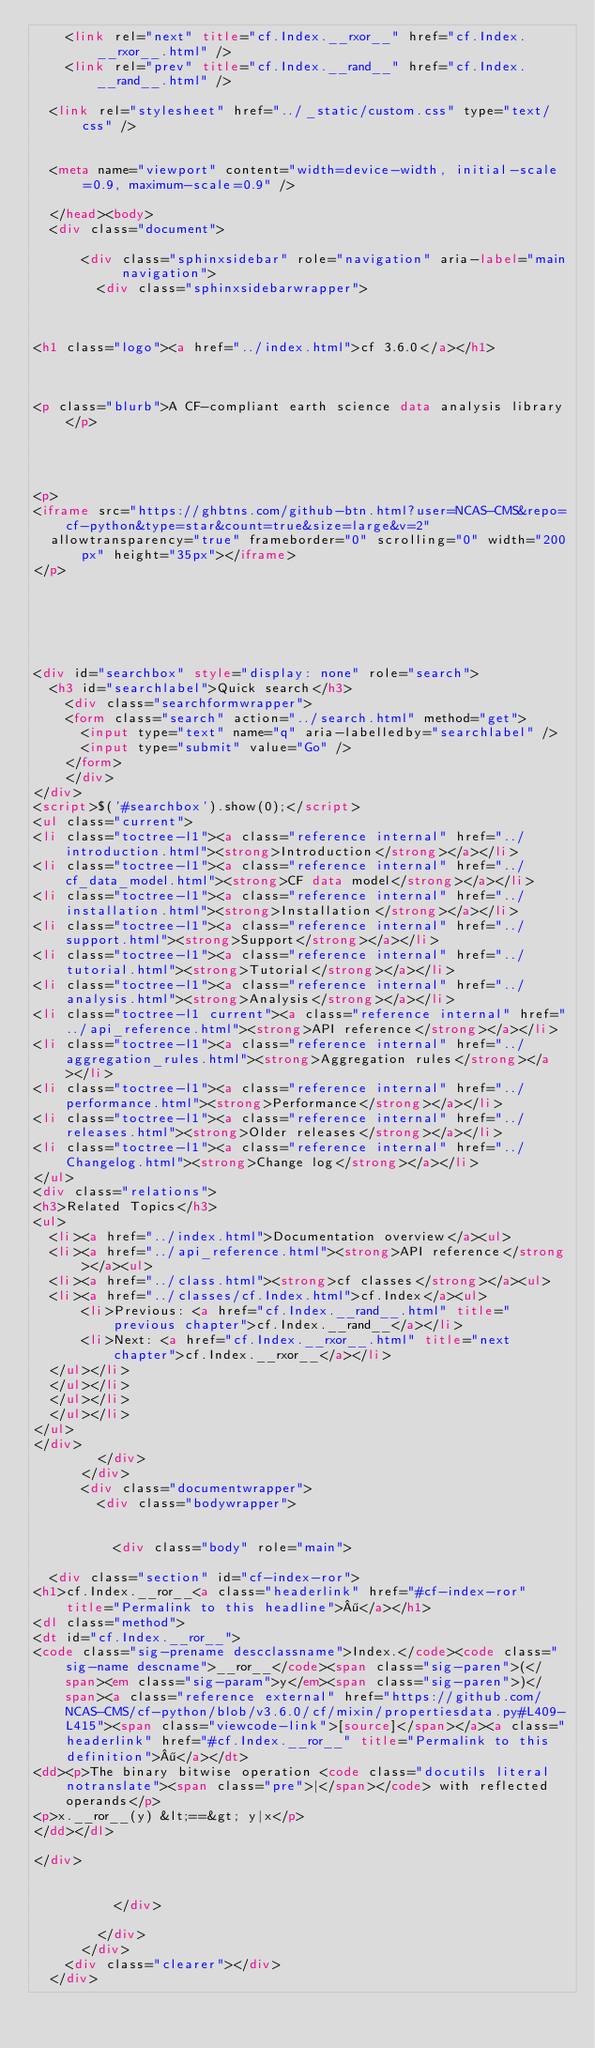Convert code to text. <code><loc_0><loc_0><loc_500><loc_500><_HTML_>    <link rel="next" title="cf.Index.__rxor__" href="cf.Index.__rxor__.html" />
    <link rel="prev" title="cf.Index.__rand__" href="cf.Index.__rand__.html" />
   
  <link rel="stylesheet" href="../_static/custom.css" type="text/css" />
  
  
  <meta name="viewport" content="width=device-width, initial-scale=0.9, maximum-scale=0.9" />

  </head><body>
  <div class="document">
    
      <div class="sphinxsidebar" role="navigation" aria-label="main navigation">
        <div class="sphinxsidebarwrapper">



<h1 class="logo"><a href="../index.html">cf 3.6.0</a></h1>



<p class="blurb">A CF-compliant earth science data analysis library</p>




<p>
<iframe src="https://ghbtns.com/github-btn.html?user=NCAS-CMS&repo=cf-python&type=star&count=true&size=large&v=2"
  allowtransparency="true" frameborder="0" scrolling="0" width="200px" height="35px"></iframe>
</p>






<div id="searchbox" style="display: none" role="search">
  <h3 id="searchlabel">Quick search</h3>
    <div class="searchformwrapper">
    <form class="search" action="../search.html" method="get">
      <input type="text" name="q" aria-labelledby="searchlabel" />
      <input type="submit" value="Go" />
    </form>
    </div>
</div>
<script>$('#searchbox').show(0);</script>
<ul class="current">
<li class="toctree-l1"><a class="reference internal" href="../introduction.html"><strong>Introduction</strong></a></li>
<li class="toctree-l1"><a class="reference internal" href="../cf_data_model.html"><strong>CF data model</strong></a></li>
<li class="toctree-l1"><a class="reference internal" href="../installation.html"><strong>Installation</strong></a></li>
<li class="toctree-l1"><a class="reference internal" href="../support.html"><strong>Support</strong></a></li>
<li class="toctree-l1"><a class="reference internal" href="../tutorial.html"><strong>Tutorial</strong></a></li>
<li class="toctree-l1"><a class="reference internal" href="../analysis.html"><strong>Analysis</strong></a></li>
<li class="toctree-l1 current"><a class="reference internal" href="../api_reference.html"><strong>API reference</strong></a></li>
<li class="toctree-l1"><a class="reference internal" href="../aggregation_rules.html"><strong>Aggregation rules</strong></a></li>
<li class="toctree-l1"><a class="reference internal" href="../performance.html"><strong>Performance</strong></a></li>
<li class="toctree-l1"><a class="reference internal" href="../releases.html"><strong>Older releases</strong></a></li>
<li class="toctree-l1"><a class="reference internal" href="../Changelog.html"><strong>Change log</strong></a></li>
</ul>
<div class="relations">
<h3>Related Topics</h3>
<ul>
  <li><a href="../index.html">Documentation overview</a><ul>
  <li><a href="../api_reference.html"><strong>API reference</strong></a><ul>
  <li><a href="../class.html"><strong>cf classes</strong></a><ul>
  <li><a href="../classes/cf.Index.html">cf.Index</a><ul>
      <li>Previous: <a href="cf.Index.__rand__.html" title="previous chapter">cf.Index.__rand__</a></li>
      <li>Next: <a href="cf.Index.__rxor__.html" title="next chapter">cf.Index.__rxor__</a></li>
  </ul></li>
  </ul></li>
  </ul></li>
  </ul></li>
</ul>
</div>
        </div>
      </div>
      <div class="documentwrapper">
        <div class="bodywrapper">
          

          <div class="body" role="main">
            
  <div class="section" id="cf-index-ror">
<h1>cf.Index.__ror__<a class="headerlink" href="#cf-index-ror" title="Permalink to this headline">¶</a></h1>
<dl class="method">
<dt id="cf.Index.__ror__">
<code class="sig-prename descclassname">Index.</code><code class="sig-name descname">__ror__</code><span class="sig-paren">(</span><em class="sig-param">y</em><span class="sig-paren">)</span><a class="reference external" href="https://github.com/NCAS-CMS/cf-python/blob/v3.6.0/cf/mixin/propertiesdata.py#L409-L415"><span class="viewcode-link">[source]</span></a><a class="headerlink" href="#cf.Index.__ror__" title="Permalink to this definition">¶</a></dt>
<dd><p>The binary bitwise operation <code class="docutils literal notranslate"><span class="pre">|</span></code> with reflected operands</p>
<p>x.__ror__(y) &lt;==&gt; y|x</p>
</dd></dl>

</div>


          </div>
          
        </div>
      </div>
    <div class="clearer"></div>
  </div></code> 